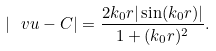Convert formula to latex. <formula><loc_0><loc_0><loc_500><loc_500>| \ v u - C | = \frac { 2 k _ { 0 } r | \sin ( k _ { 0 } r ) | } { 1 + ( k _ { 0 } r ) ^ { 2 } } .</formula> 